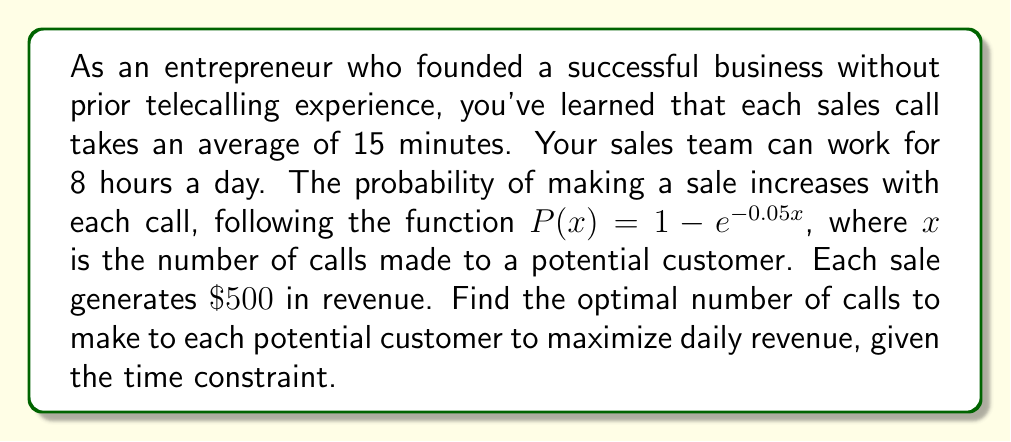Can you solve this math problem? Let's approach this step-by-step:

1) First, we need to set up our revenue function. The expected revenue per customer is:

   $R(x) = 500 \cdot P(x) = 500 \cdot (1 - e^{-0.05x})$

2) Given an 8-hour workday and 15 minutes per call, the maximum number of calls per day is:

   $\text{Max calls} = \frac{8 \text{ hours} \cdot 60 \text{ min/hour}}{15 \text{ min/call}} = 32 \text{ calls}$

3) If we make $x$ calls per customer, the number of customers we can reach in a day is:

   $\text{Customers} = \frac{32}{x}$

4) Therefore, our daily revenue function is:

   $R_{\text{daily}}(x) = \frac{32}{x} \cdot 500 \cdot (1 - e^{-0.05x}) = \frac{16000}{x} \cdot (1 - e^{-0.05x})$

5) To find the maximum, we differentiate and set to zero:

   $\frac{d}{dx}R_{\text{daily}}(x) = 16000 \cdot \frac{-(1-e^{-0.05x}) + 0.05xe^{-0.05x}}{x^2} = 0$

6) Simplifying:

   $-(1-e^{-0.05x}) + 0.05xe^{-0.05x} = 0$
   $1-e^{-0.05x} = 0.05xe^{-0.05x}$

7) This equation can't be solved algebraically. We need to use numerical methods to find that the solution is approximately $x \approx 6.18$.

8) Since we can only make a whole number of calls, we need to check both 6 and 7 calls in our original function:

   $R_{\text{daily}}(6) = \frac{16000}{6} \cdot (1 - e^{-0.05 \cdot 6}) \approx 2245.92$
   $R_{\text{daily}}(7) = \frac{16000}{7} \cdot (1 - e^{-0.05 \cdot 7}) \approx 2246.34$
Answer: The optimal number of calls to make to each potential customer is 7, which maximizes the daily revenue at approximately $\$2246.34$. 